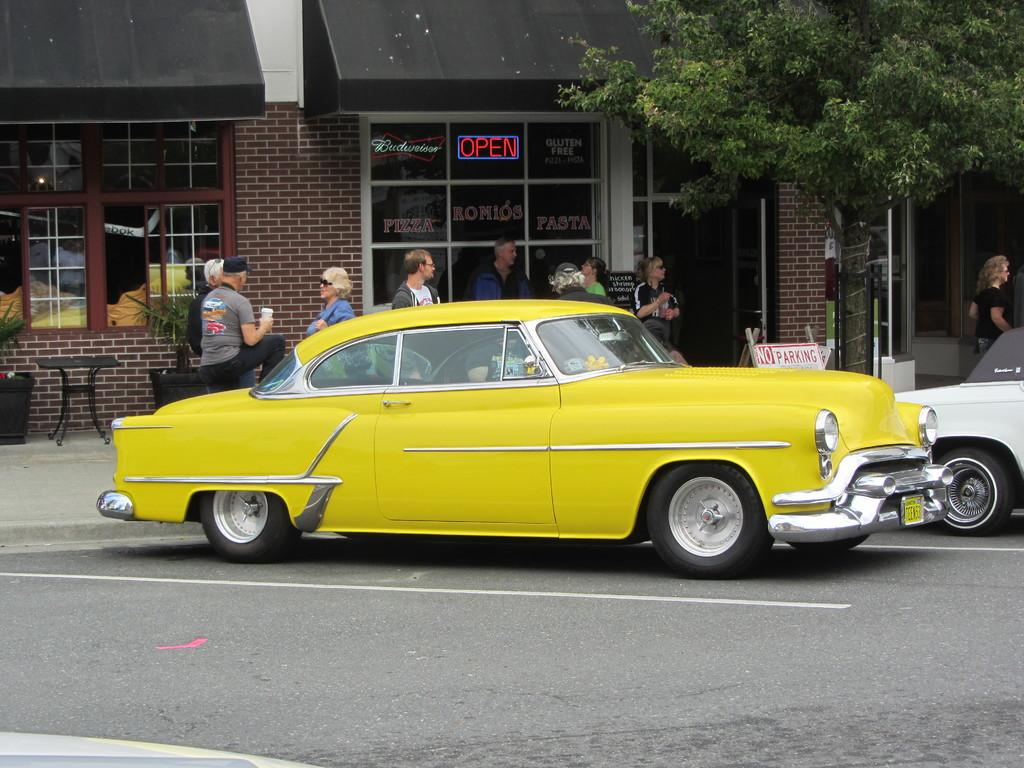What type of vehicles can be seen in the image? There are cars in the image. Who or what else is present in the image? There are people and chairs in the image. What natural element is visible in the image? There is a tree in the image. What type of man-made structure is present in the image? There is a building in the image. What type of cloth is being used to operate the cars in the image? There is no cloth present in the image, and cloth is not used to operate cars. How does the comfort level of the chairs affect the people in the image? The comfort level of the chairs cannot be determined from the image, as there is no information about the chairs' comfort. 